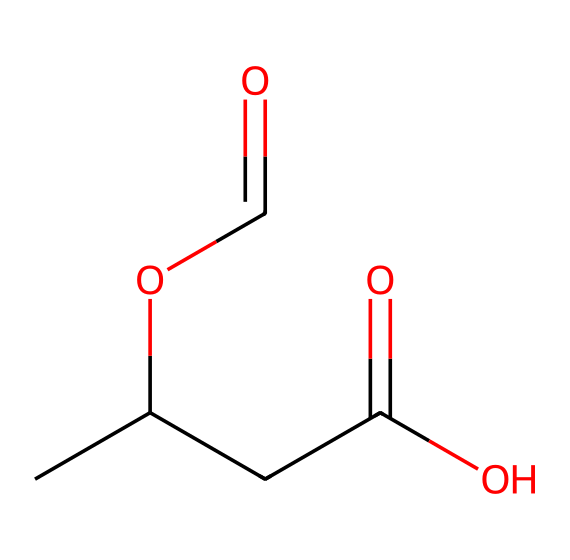What is the total number of carbon atoms in this molecule? In the given SMILES representation, we can count the carbon (C) atoms. The structure contains a total of 5 carbon atoms from the chain and branches depicted.
Answer: 5 How many oxygen atoms are present in the structure? By analyzing the SMILES, we can see that there are 3 oxygen atoms (O) involved in different functional groups (carboxylic acid and ester).
Answer: 3 What functional groups are indicated in this structure? The chemical contains a carboxylic acid (indicated by the presence of -COOH) and an ester (represented by -COO-). These can be identified by their characteristic arrangements of carbon, oxygen, and hydrogen atoms.
Answer: carboxylic acid, ester What does the presence of the carboxylic acid group suggest about this polymer? The carboxylic acid functional group is associated with properties like solubility in water and acidity, which may enhance biodegradability when compared to some non-biodegradable plastics. Therefore, it indicates that this polymer has biodegradable properties.
Answer: biodegradable properties How do the ester linkages in PHAs contribute to their properties? Ester linkages provide flexibility in the polymer chain, which contributes to the mechanical properties of the material, such as elasticity and thermal properties, making them suitable for various applications.
Answer: flexibility and elasticity What type of bond connects the carbon atoms in this molecule? The carbon atoms in this molecule are primarily connected by single covalent bonds, as inferred from the SMILES representation, which shows no indications of double or triple bonds between the carbon atoms.
Answer: single covalent bonds 